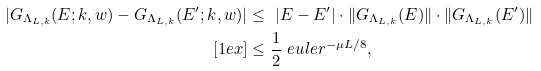<formula> <loc_0><loc_0><loc_500><loc_500>| G _ { \Lambda _ { L , k } } ( E ; k , w ) - G _ { \Lambda _ { L , k } } ( E ^ { \prime } ; k , w ) | & \leq \ | E - E ^ { \prime } | \cdot \| G _ { \Lambda _ { L , k } } ( E ) \| \cdot \| G _ { \Lambda _ { L , k } } ( E ^ { \prime } ) \| \\ [ 1 e x ] & \leq \frac { 1 } { 2 } \ e u l e r ^ { - \mu L / 8 } ,</formula> 